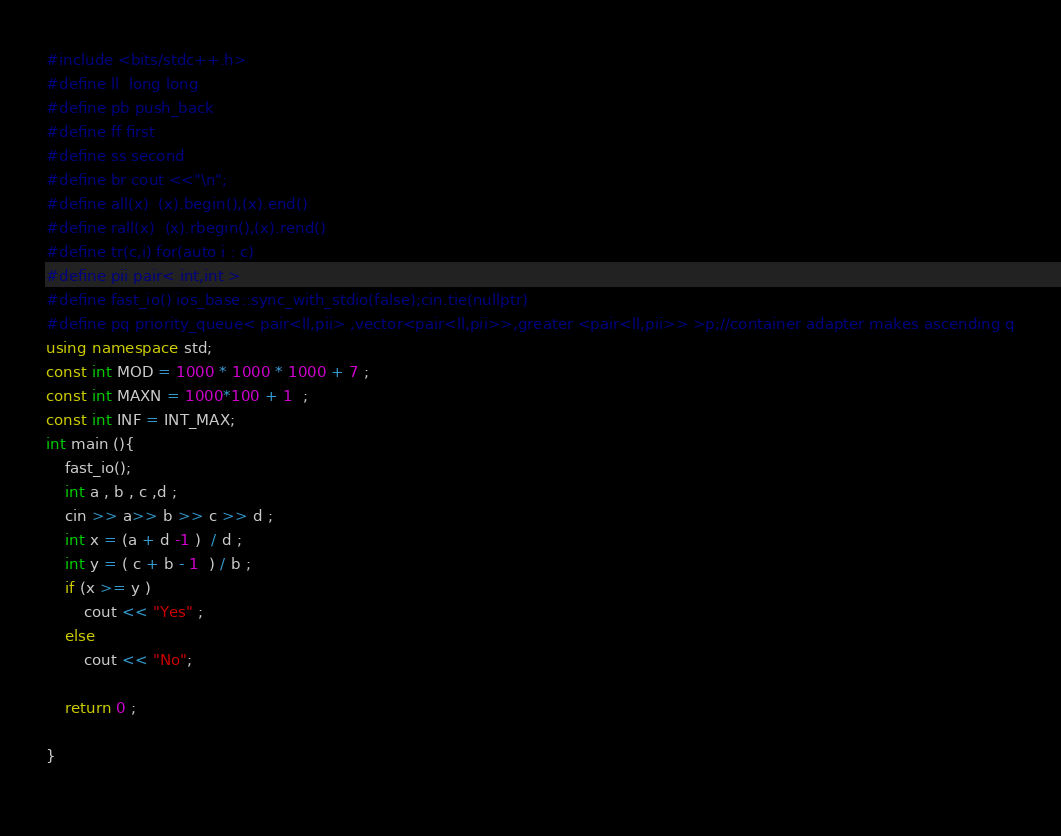Convert code to text. <code><loc_0><loc_0><loc_500><loc_500><_C++_>#include <bits/stdc++.h>
#define ll  long long
#define pb push_back
#define ff first
#define ss second
#define br cout <<"\n";
#define all(x)  (x).begin(),(x).end()
#define rall(x)  (x).rbegin(),(x).rend()
#define tr(c,i) for(auto i : c)
#define pii pair< int,int >
#define fast_io() ios_base::sync_with_stdio(false);cin.tie(nullptr)
#define pq priority_queue< pair<ll,pii> ,vector<pair<ll,pii>>,greater <pair<ll,pii>> >p;//container adapter makes ascending q
using namespace std;
const int MOD = 1000 * 1000 * 1000 + 7 ;
const int MAXN = 1000*100 + 1  ;
const int INF = INT_MAX;
int main (){
	fast_io();
	int a , b , c ,d ;
	cin >> a>> b >> c >> d ;
	int x = (a + d -1 )  / d ; 	
	int y = ( c + b - 1  ) / b ;
	if (x >= y )
		cout << "Yes" ;
	else
		cout << "No";
 	 
	return 0 ;

}
 
</code> 